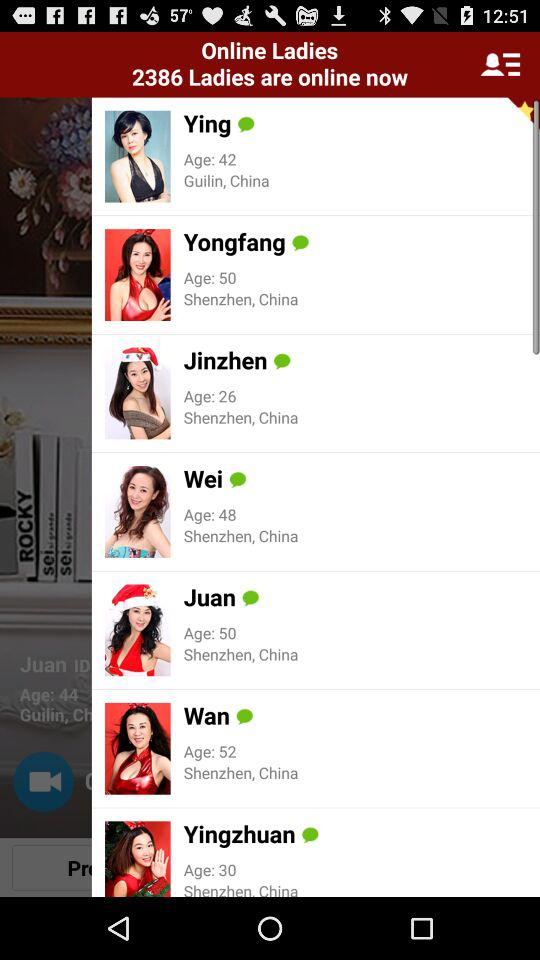What is the name of the application?
When the provided information is insufficient, respond with <no answer>. <no answer> 